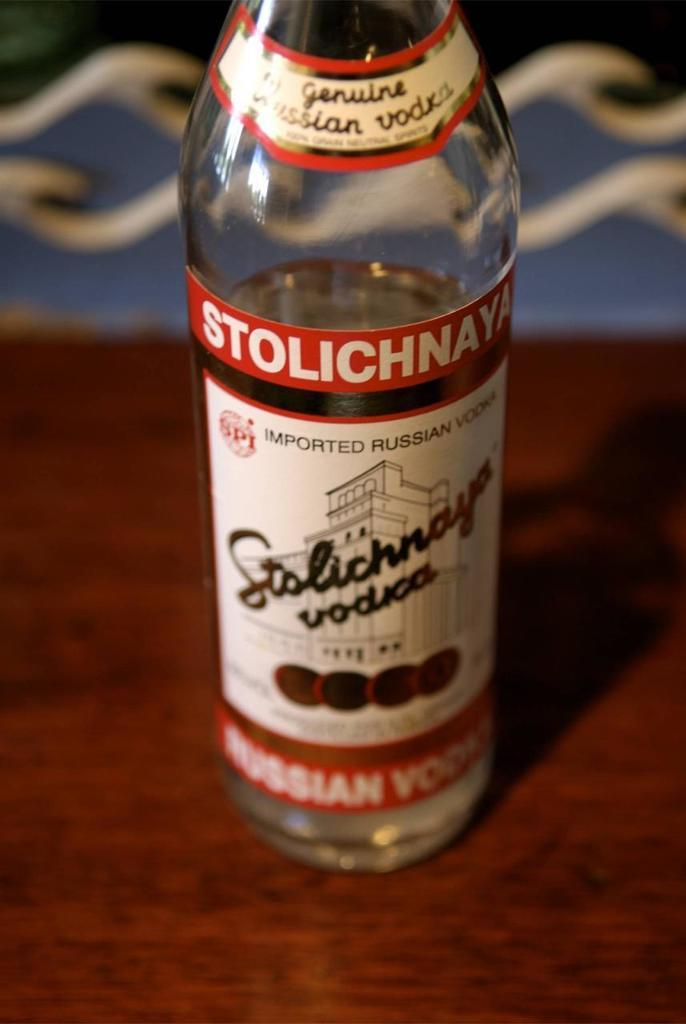Provide a one-sentence caption for the provided image. a bottle of STOLICHNAYA vodka alcohol that is opened. 